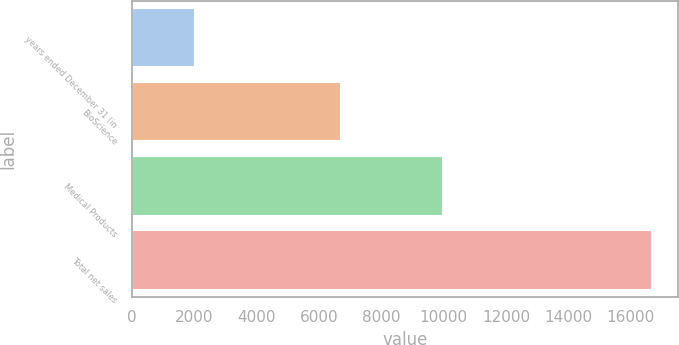Convert chart. <chart><loc_0><loc_0><loc_500><loc_500><bar_chart><fcel>years ended December 31 (in<fcel>BioScience<fcel>Medical Products<fcel>Total net sales<nl><fcel>2014<fcel>6699<fcel>9972<fcel>16671<nl></chart> 